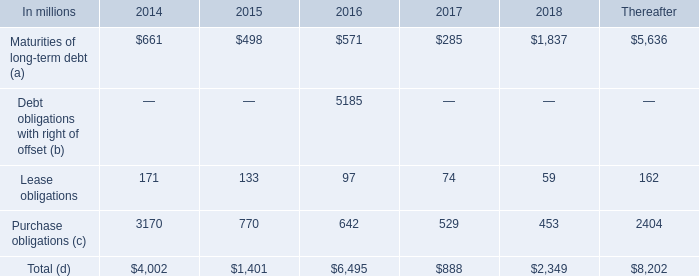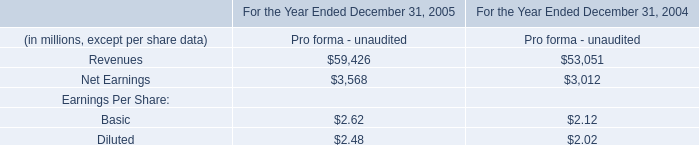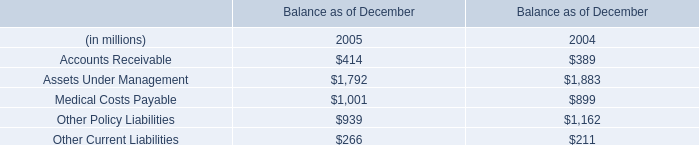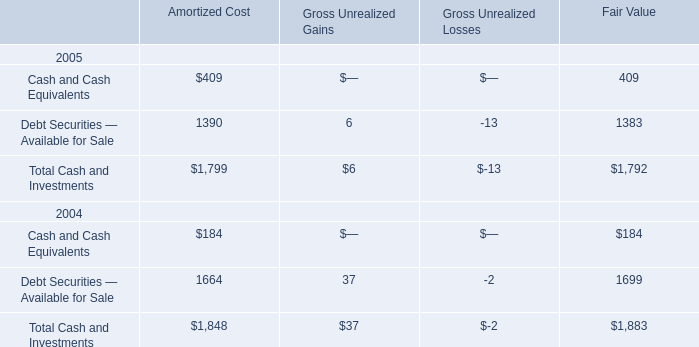What's the average of Balance as of December in 2005? (in million) 
Computations: (((((414 + 1792) + 1001) + 939) + 266) / 5)
Answer: 882.4. 